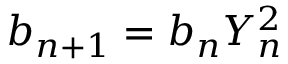<formula> <loc_0><loc_0><loc_500><loc_500>b _ { n + 1 } = b _ { n } Y _ { n } ^ { 2 }</formula> 